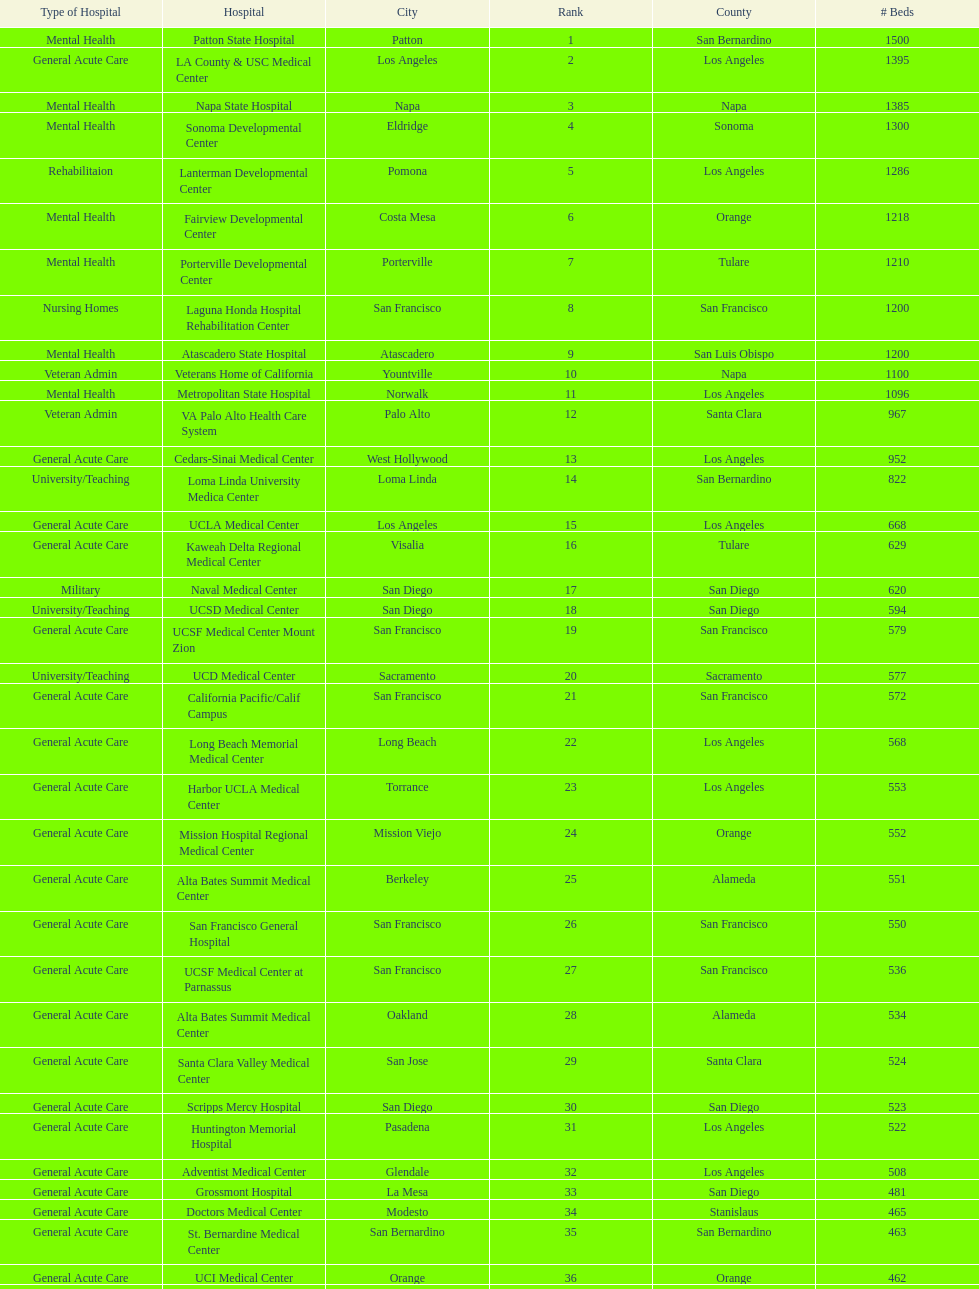How many more general acute care hospitals are there in california than rehabilitation hospitals? 33. 